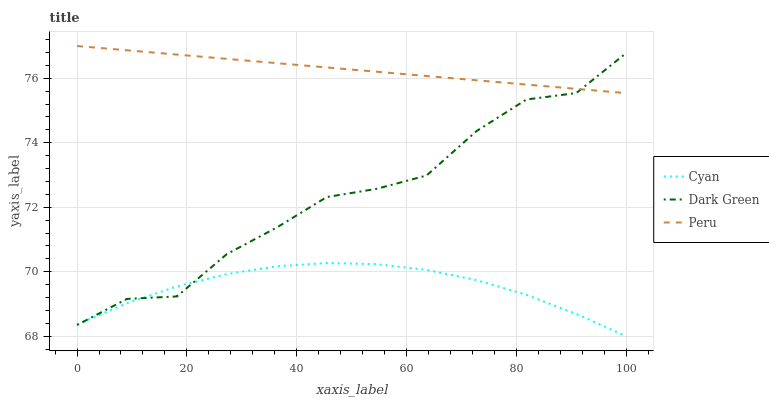Does Cyan have the minimum area under the curve?
Answer yes or no. Yes. Does Peru have the maximum area under the curve?
Answer yes or no. Yes. Does Dark Green have the minimum area under the curve?
Answer yes or no. No. Does Dark Green have the maximum area under the curve?
Answer yes or no. No. Is Peru the smoothest?
Answer yes or no. Yes. Is Dark Green the roughest?
Answer yes or no. Yes. Is Dark Green the smoothest?
Answer yes or no. No. Is Peru the roughest?
Answer yes or no. No. Does Cyan have the lowest value?
Answer yes or no. Yes. Does Dark Green have the lowest value?
Answer yes or no. No. Does Peru have the highest value?
Answer yes or no. Yes. Does Dark Green have the highest value?
Answer yes or no. No. Is Cyan less than Peru?
Answer yes or no. Yes. Is Peru greater than Cyan?
Answer yes or no. Yes. Does Cyan intersect Dark Green?
Answer yes or no. Yes. Is Cyan less than Dark Green?
Answer yes or no. No. Is Cyan greater than Dark Green?
Answer yes or no. No. Does Cyan intersect Peru?
Answer yes or no. No. 